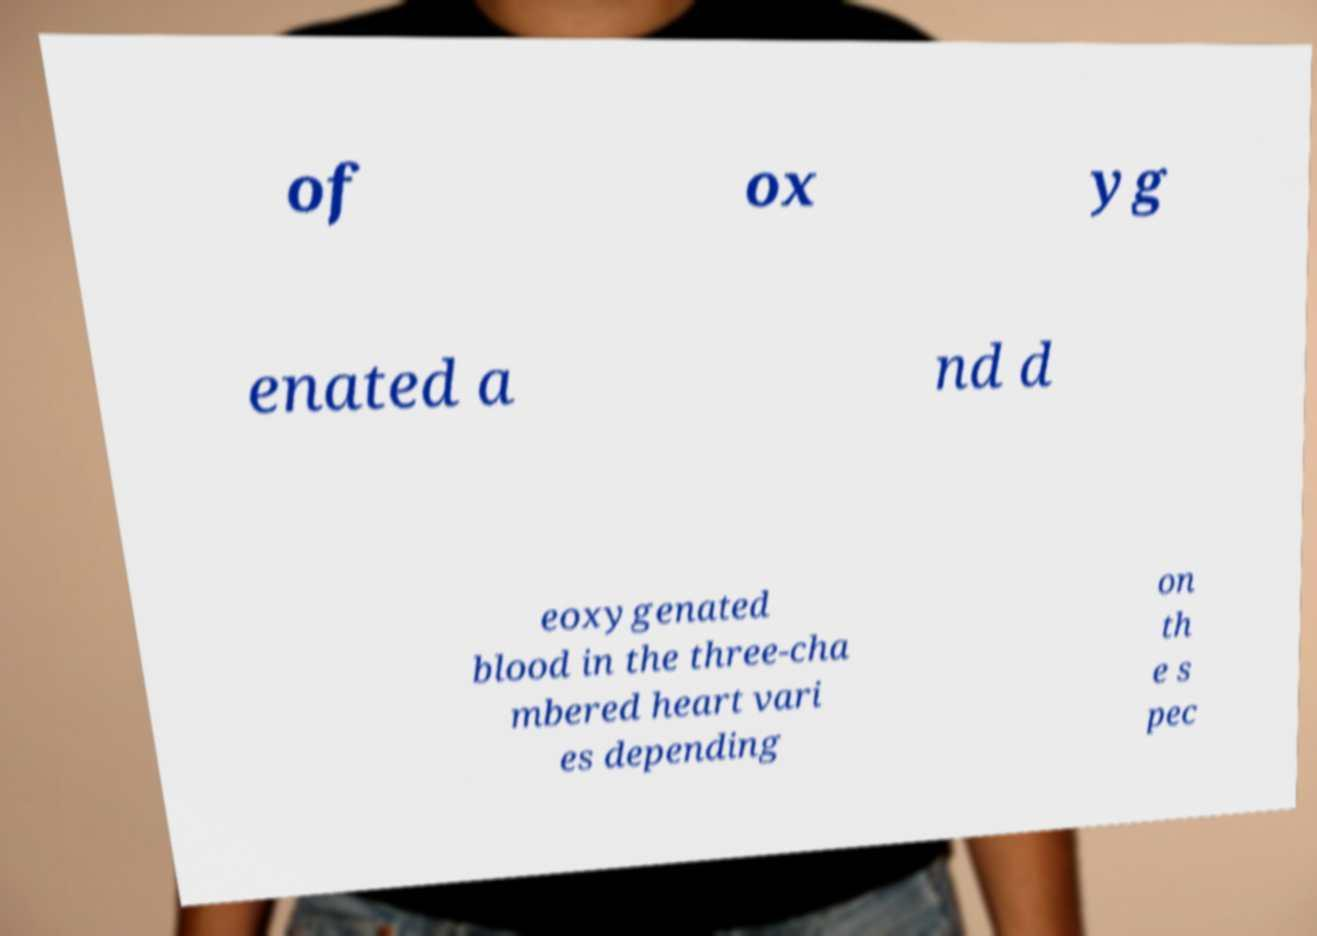Could you extract and type out the text from this image? of ox yg enated a nd d eoxygenated blood in the three-cha mbered heart vari es depending on th e s pec 